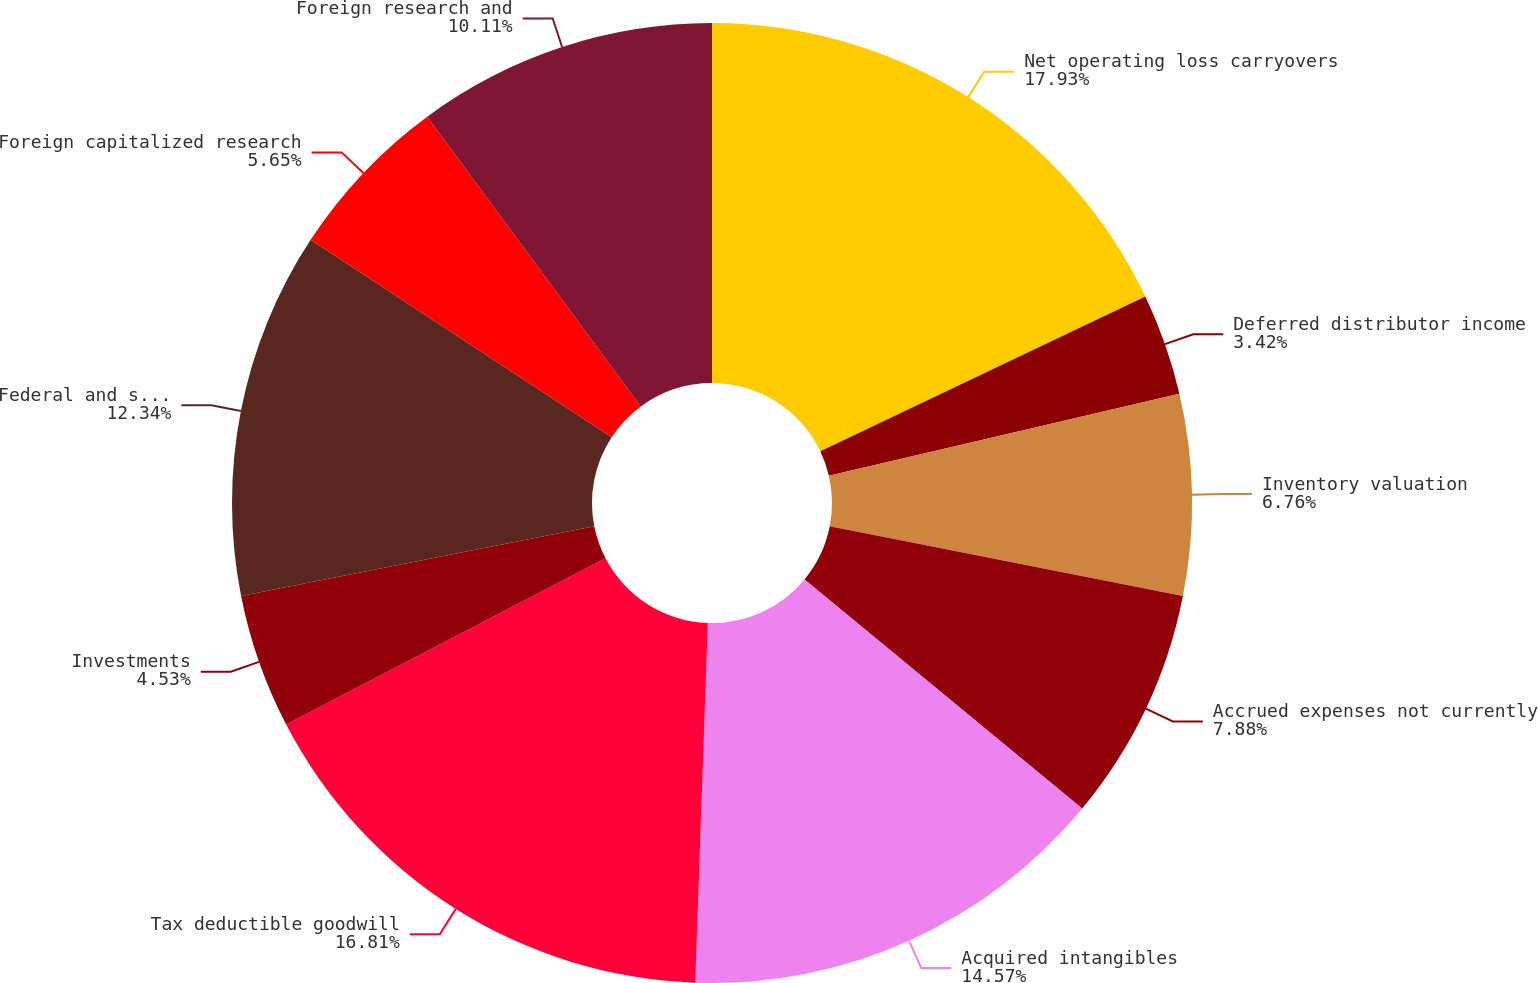Convert chart. <chart><loc_0><loc_0><loc_500><loc_500><pie_chart><fcel>Net operating loss carryovers<fcel>Deferred distributor income<fcel>Inventory valuation<fcel>Accrued expenses not currently<fcel>Acquired intangibles<fcel>Tax deductible goodwill<fcel>Investments<fcel>Federal and state tax credit<fcel>Foreign capitalized research<fcel>Foreign research and<nl><fcel>17.92%<fcel>3.42%<fcel>6.76%<fcel>7.88%<fcel>14.57%<fcel>16.81%<fcel>4.53%<fcel>12.34%<fcel>5.65%<fcel>10.11%<nl></chart> 